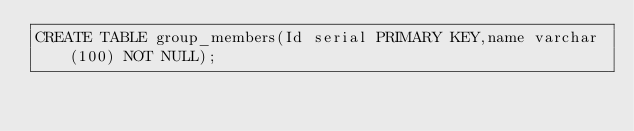<code> <loc_0><loc_0><loc_500><loc_500><_SQL_>CREATE TABLE group_members(Id serial PRIMARY KEY,name varchar(100) NOT NULL);</code> 